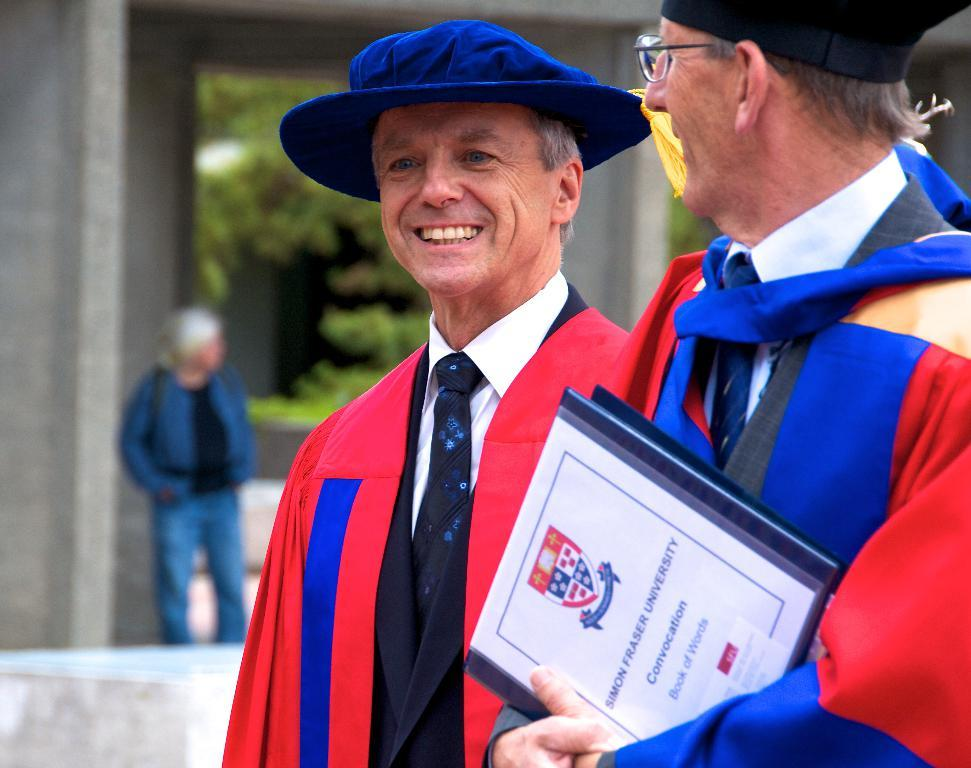How many men are in the image? There are two men in the image. What are the men wearing around their necks? The men are wearing ties. What type of headwear are the men wearing? The men are wearing caps. What expression do the men have in the image? The men are smiling. Can you describe the person in the background of the image? There is a person standing in the background of the image, but no specific details are provided. What can be seen in the distance behind the men? Trees are visible in the background of the image. What type of hole can be seen in the image? There is no hole present in the image. What kind of vase is placed on the table in the image? There is no table or vase present in the image. 